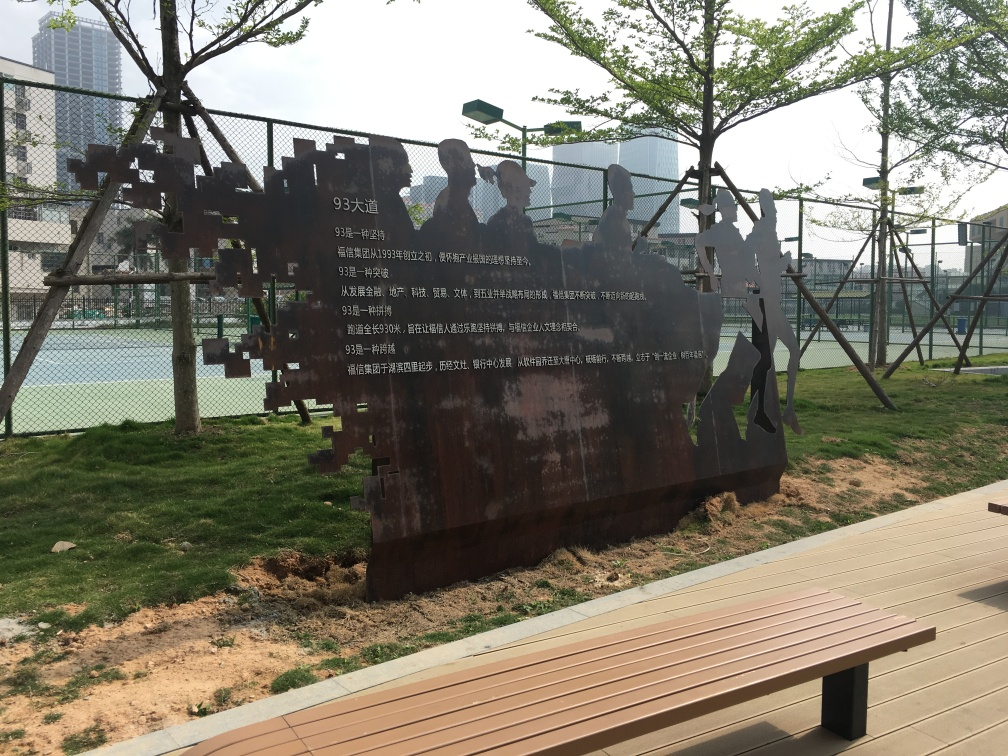What does the text on the art piece signify? While the specific details of the text on the art piece aren't clear from this image, it's reasonable to infer that the text could provide context or commentary related to the artwork. It could be a description of the piece, the artist's name, or an inscription related to the theme of the installation. Text on art pieces like this often adds a narrative layer, inviting viewers to reflect on the message or history intertwined with the visual experience. 